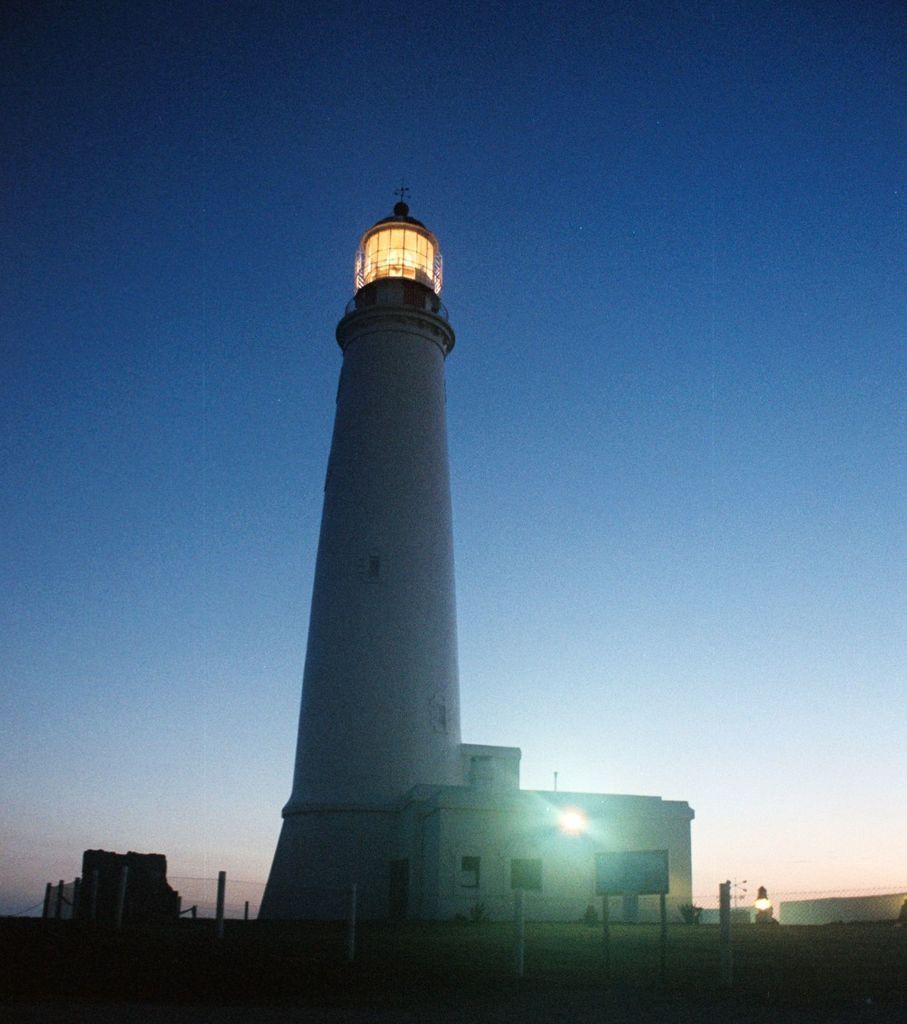Describe this image in one or two sentences. In the center of the image there are buildings, boards, lights. In the background of the image there is sky. 